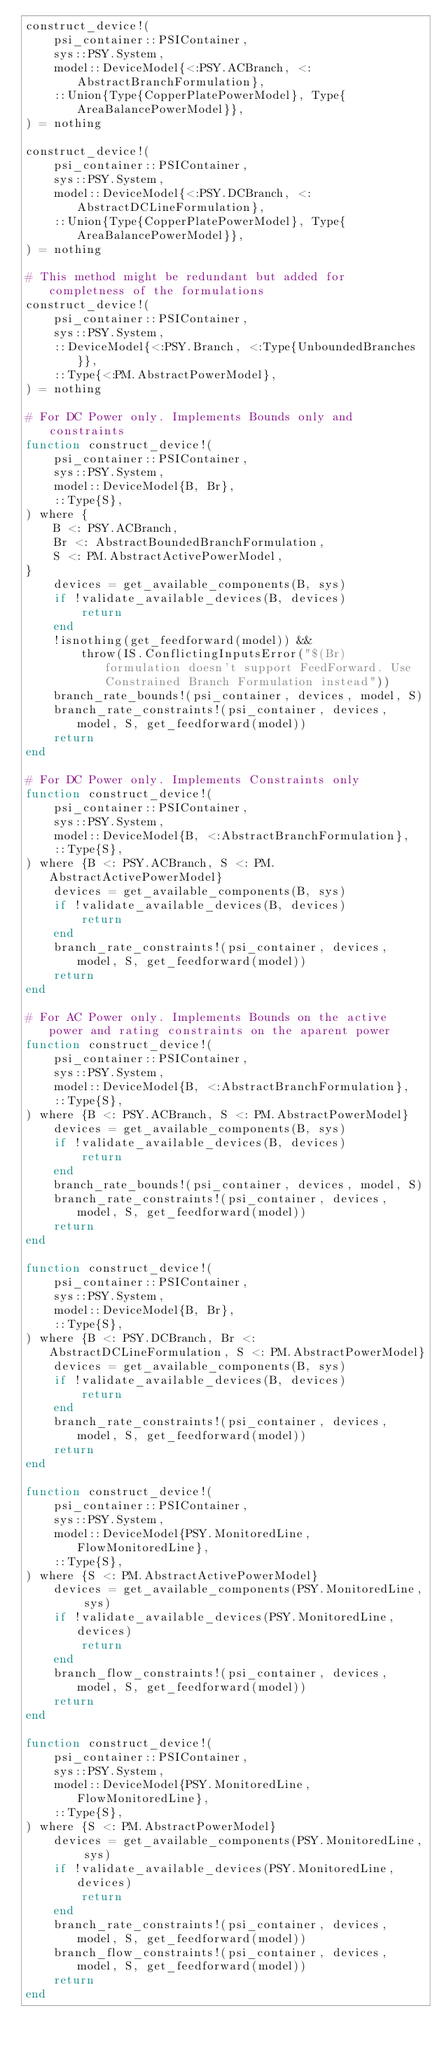<code> <loc_0><loc_0><loc_500><loc_500><_Julia_>construct_device!(
    psi_container::PSIContainer,
    sys::PSY.System,
    model::DeviceModel{<:PSY.ACBranch, <:AbstractBranchFormulation},
    ::Union{Type{CopperPlatePowerModel}, Type{AreaBalancePowerModel}},
) = nothing

construct_device!(
    psi_container::PSIContainer,
    sys::PSY.System,
    model::DeviceModel{<:PSY.DCBranch, <:AbstractDCLineFormulation},
    ::Union{Type{CopperPlatePowerModel}, Type{AreaBalancePowerModel}},
) = nothing

# This method might be redundant but added for completness of the formulations
construct_device!(
    psi_container::PSIContainer,
    sys::PSY.System,
    ::DeviceModel{<:PSY.Branch, <:Type{UnboundedBranches}},
    ::Type{<:PM.AbstractPowerModel},
) = nothing

# For DC Power only. Implements Bounds only and constraints
function construct_device!(
    psi_container::PSIContainer,
    sys::PSY.System,
    model::DeviceModel{B, Br},
    ::Type{S},
) where {
    B <: PSY.ACBranch,
    Br <: AbstractBoundedBranchFormulation,
    S <: PM.AbstractActivePowerModel,
}
    devices = get_available_components(B, sys)
    if !validate_available_devices(B, devices)
        return
    end
    !isnothing(get_feedforward(model)) &&
        throw(IS.ConflictingInputsError("$(Br) formulation doesn't support FeedForward. Use Constrained Branch Formulation instead"))
    branch_rate_bounds!(psi_container, devices, model, S)
    branch_rate_constraints!(psi_container, devices, model, S, get_feedforward(model))
    return
end

# For DC Power only. Implements Constraints only
function construct_device!(
    psi_container::PSIContainer,
    sys::PSY.System,
    model::DeviceModel{B, <:AbstractBranchFormulation},
    ::Type{S},
) where {B <: PSY.ACBranch, S <: PM.AbstractActivePowerModel}
    devices = get_available_components(B, sys)
    if !validate_available_devices(B, devices)
        return
    end
    branch_rate_constraints!(psi_container, devices, model, S, get_feedforward(model))
    return
end

# For AC Power only. Implements Bounds on the active power and rating constraints on the aparent power
function construct_device!(
    psi_container::PSIContainer,
    sys::PSY.System,
    model::DeviceModel{B, <:AbstractBranchFormulation},
    ::Type{S},
) where {B <: PSY.ACBranch, S <: PM.AbstractPowerModel}
    devices = get_available_components(B, sys)
    if !validate_available_devices(B, devices)
        return
    end
    branch_rate_bounds!(psi_container, devices, model, S)
    branch_rate_constraints!(psi_container, devices, model, S, get_feedforward(model))
    return
end

function construct_device!(
    psi_container::PSIContainer,
    sys::PSY.System,
    model::DeviceModel{B, Br},
    ::Type{S},
) where {B <: PSY.DCBranch, Br <: AbstractDCLineFormulation, S <: PM.AbstractPowerModel}
    devices = get_available_components(B, sys)
    if !validate_available_devices(B, devices)
        return
    end
    branch_rate_constraints!(psi_container, devices, model, S, get_feedforward(model))
    return
end

function construct_device!(
    psi_container::PSIContainer,
    sys::PSY.System,
    model::DeviceModel{PSY.MonitoredLine, FlowMonitoredLine},
    ::Type{S},
) where {S <: PM.AbstractActivePowerModel}
    devices = get_available_components(PSY.MonitoredLine, sys)
    if !validate_available_devices(PSY.MonitoredLine, devices)
        return
    end
    branch_flow_constraints!(psi_container, devices, model, S, get_feedforward(model))
    return
end

function construct_device!(
    psi_container::PSIContainer,
    sys::PSY.System,
    model::DeviceModel{PSY.MonitoredLine, FlowMonitoredLine},
    ::Type{S},
) where {S <: PM.AbstractPowerModel}
    devices = get_available_components(PSY.MonitoredLine, sys)
    if !validate_available_devices(PSY.MonitoredLine, devices)
        return
    end
    branch_rate_constraints!(psi_container, devices, model, S, get_feedforward(model))
    branch_flow_constraints!(psi_container, devices, model, S, get_feedforward(model))
    return
end
</code> 